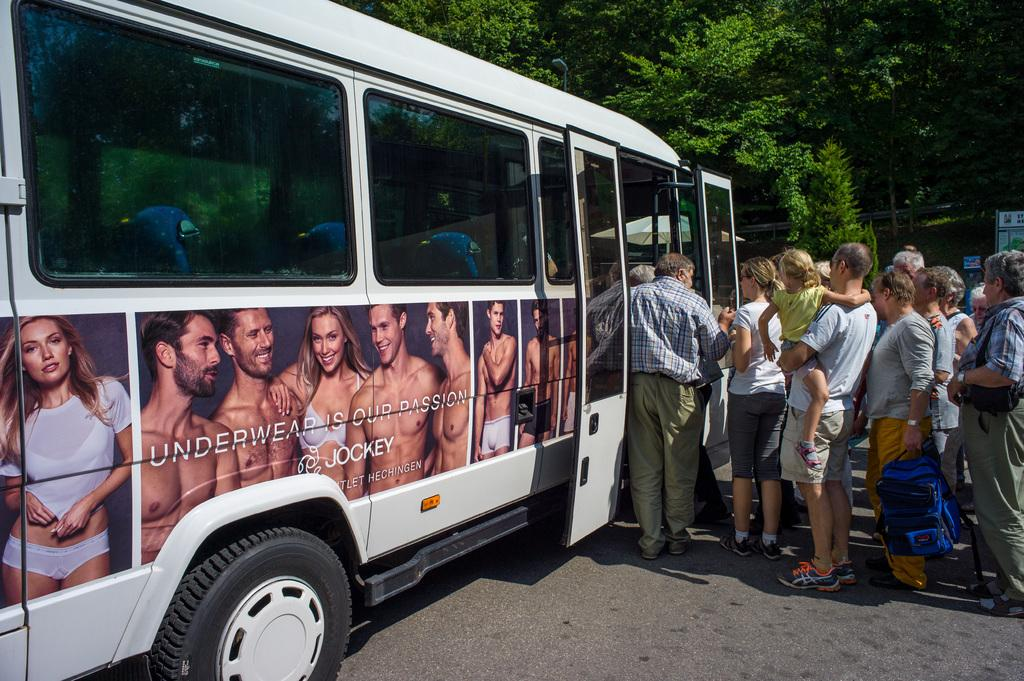<image>
Offer a succinct explanation of the picture presented. A bus with an ad for Jockey underwear on the side has a bunch of people getting on it. 